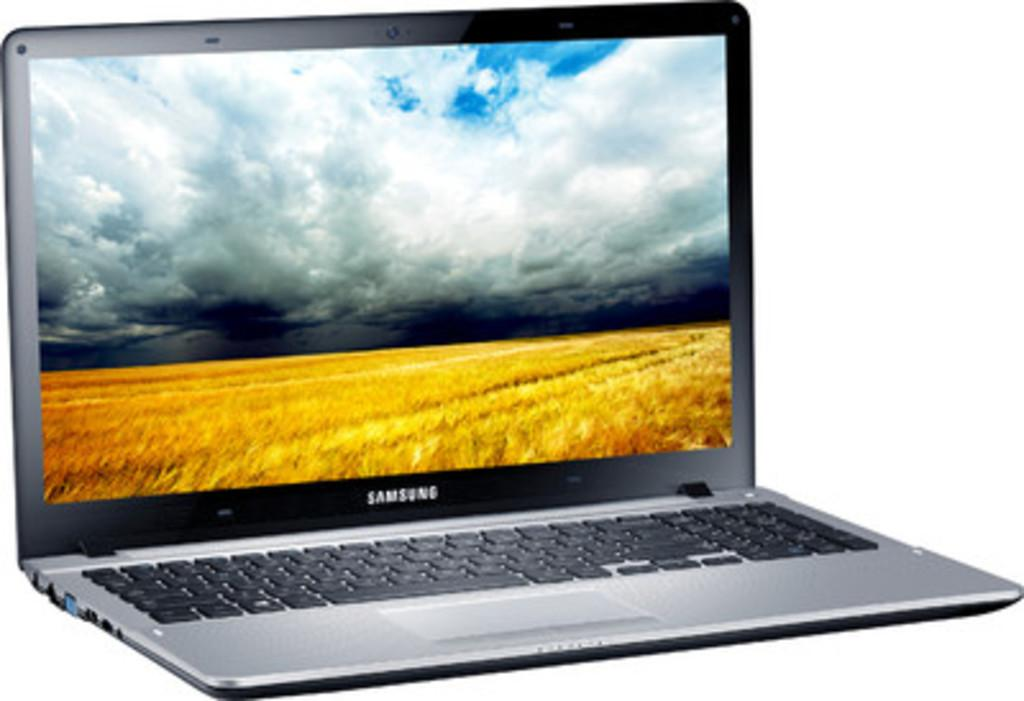<image>
Render a clear and concise summary of the photo. The laptop show here is from the company of Samsung 